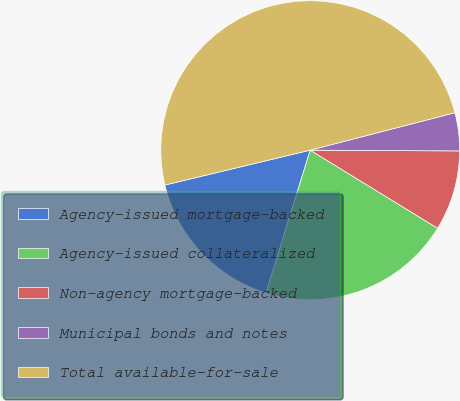Convert chart to OTSL. <chart><loc_0><loc_0><loc_500><loc_500><pie_chart><fcel>Agency-issued mortgage-backed<fcel>Agency-issued collateralized<fcel>Non-agency mortgage-backed<fcel>Municipal bonds and notes<fcel>Total available-for-sale<nl><fcel>16.47%<fcel>21.03%<fcel>8.67%<fcel>4.11%<fcel>49.72%<nl></chart> 